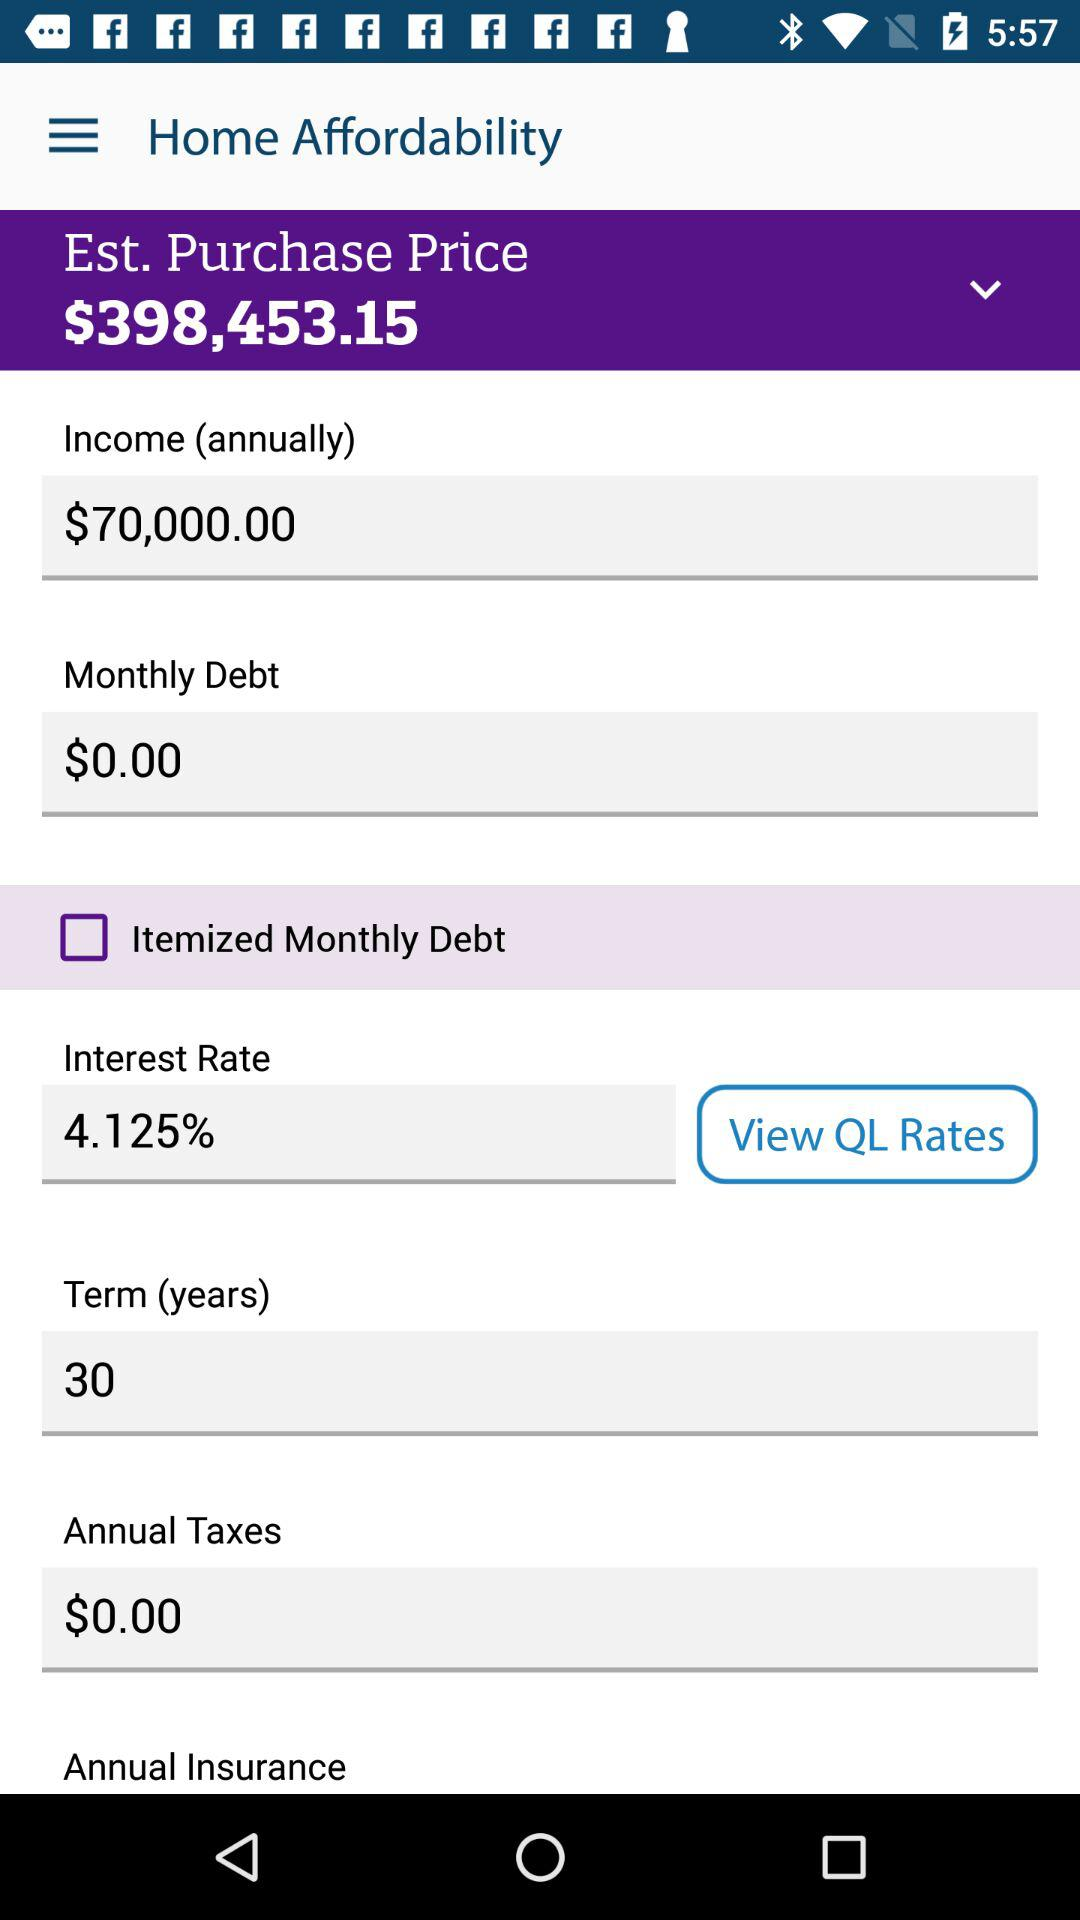What is the annual income? The annual income is $70,000.00. 